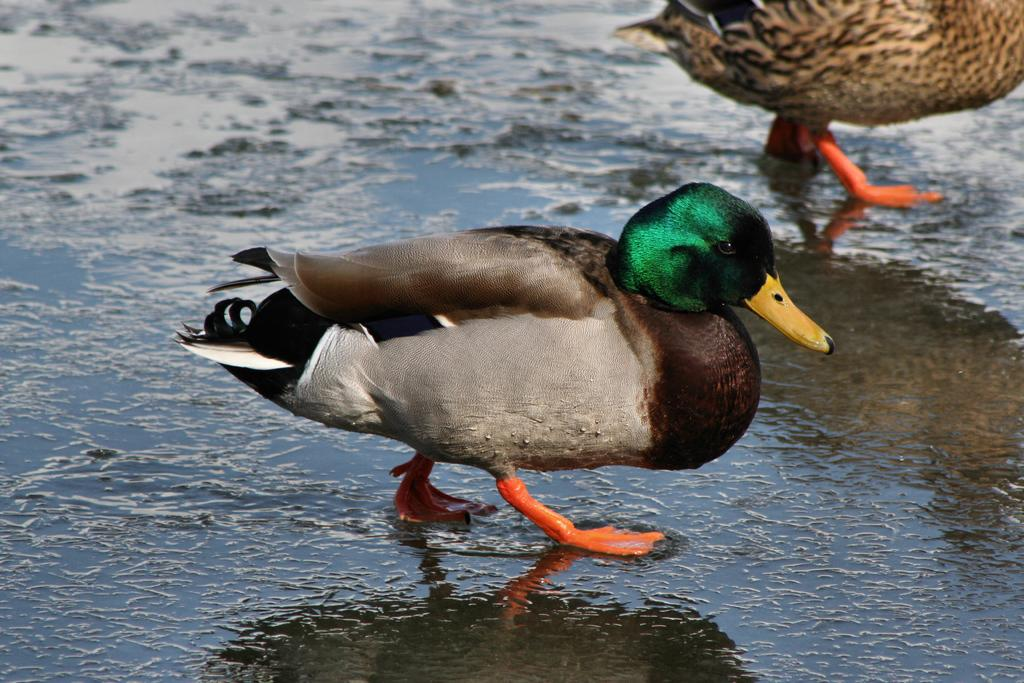What type of animals are on the ground in the image? There are birds on the ground in the image. What type of winter cover is visible in the image? There is no mention of winter or a cover in the image, as it only features birds on the ground. 